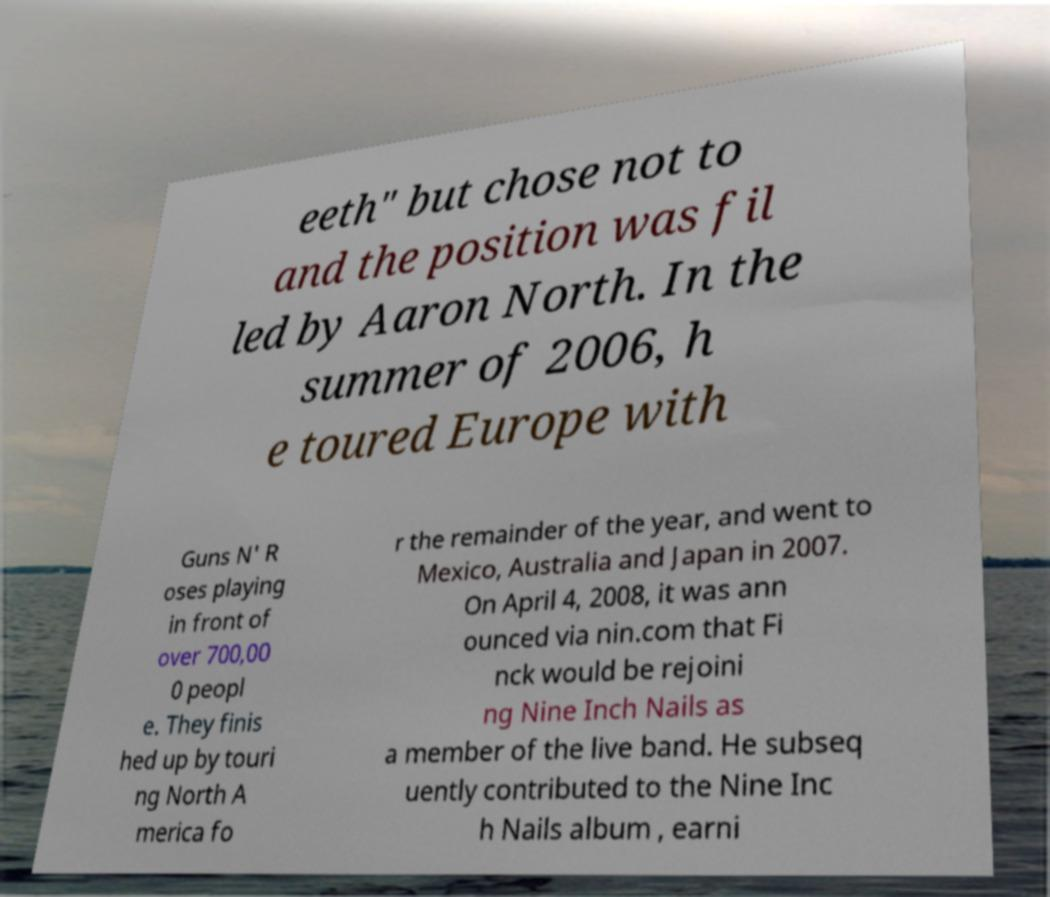Can you accurately transcribe the text from the provided image for me? eeth" but chose not to and the position was fil led by Aaron North. In the summer of 2006, h e toured Europe with Guns N' R oses playing in front of over 700,00 0 peopl e. They finis hed up by touri ng North A merica fo r the remainder of the year, and went to Mexico, Australia and Japan in 2007. On April 4, 2008, it was ann ounced via nin.com that Fi nck would be rejoini ng Nine Inch Nails as a member of the live band. He subseq uently contributed to the Nine Inc h Nails album , earni 